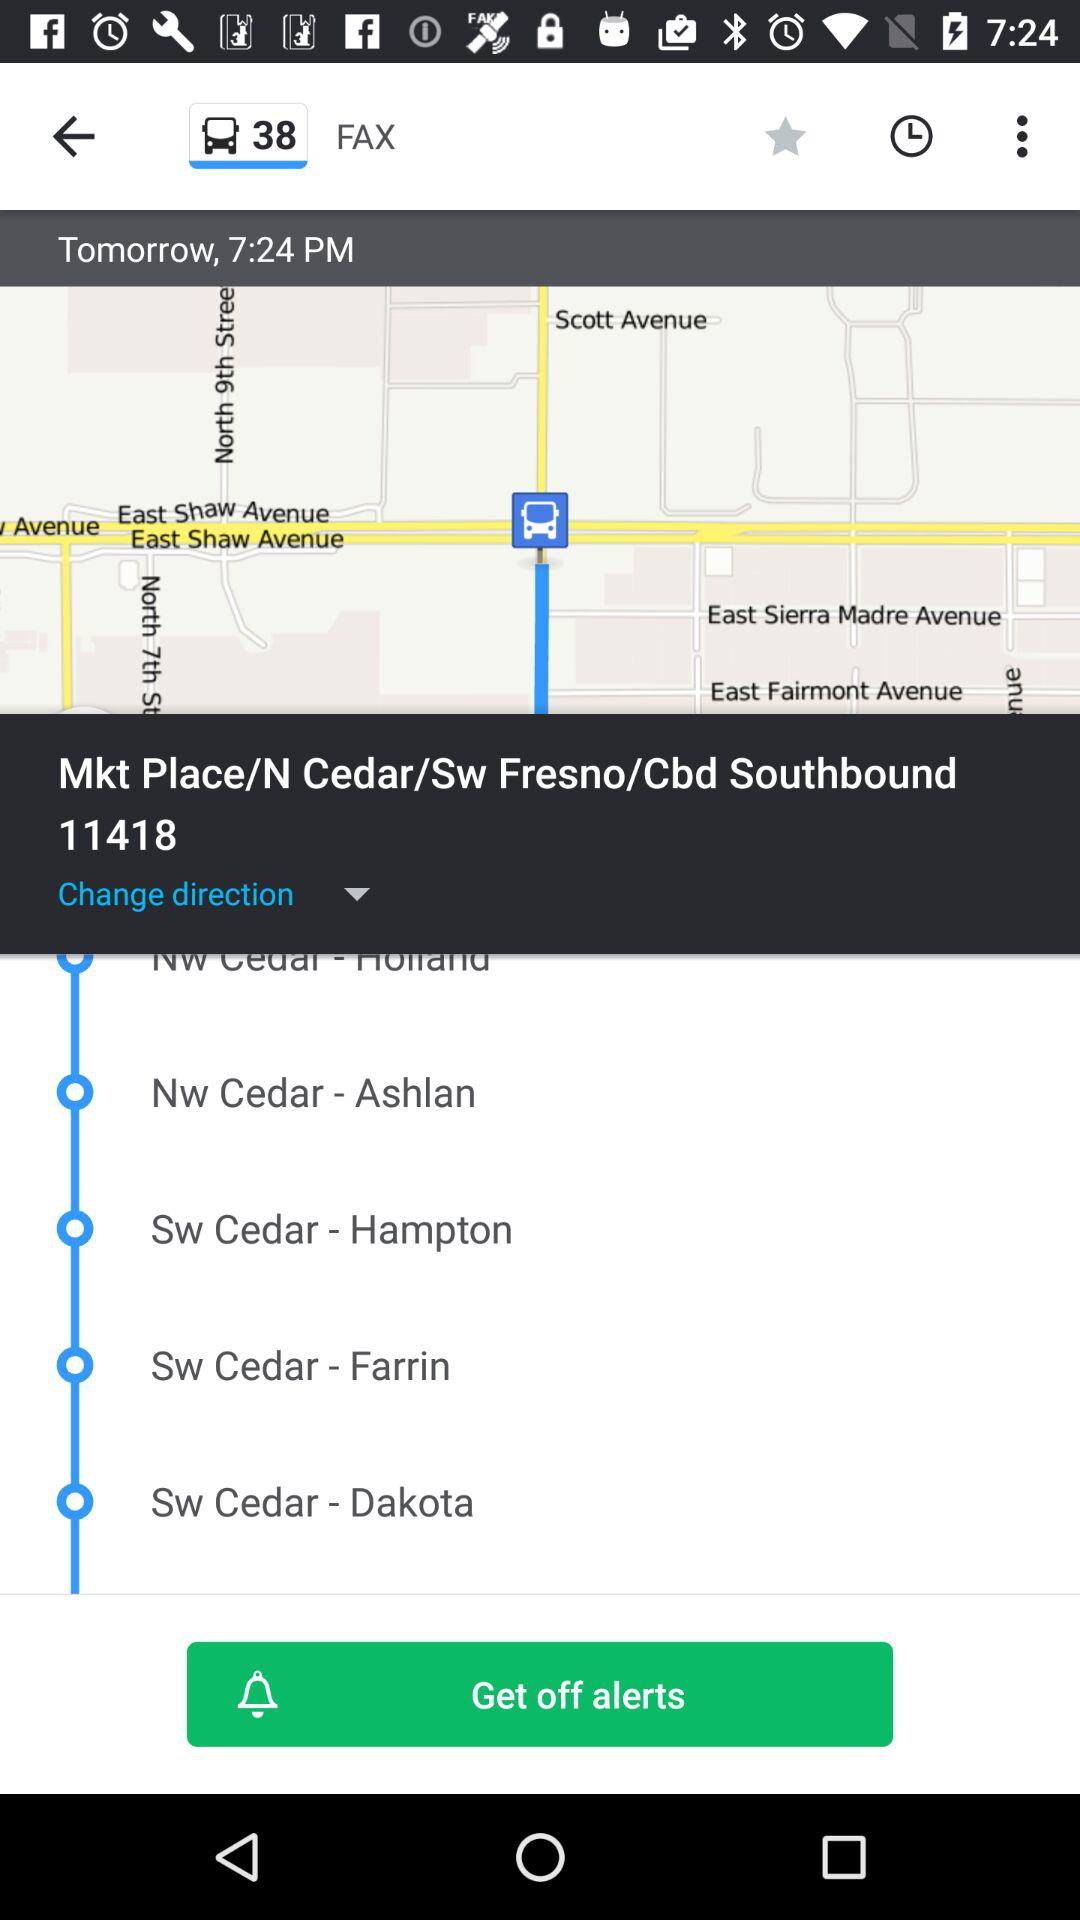What is the time? It is 7:24 PM. 